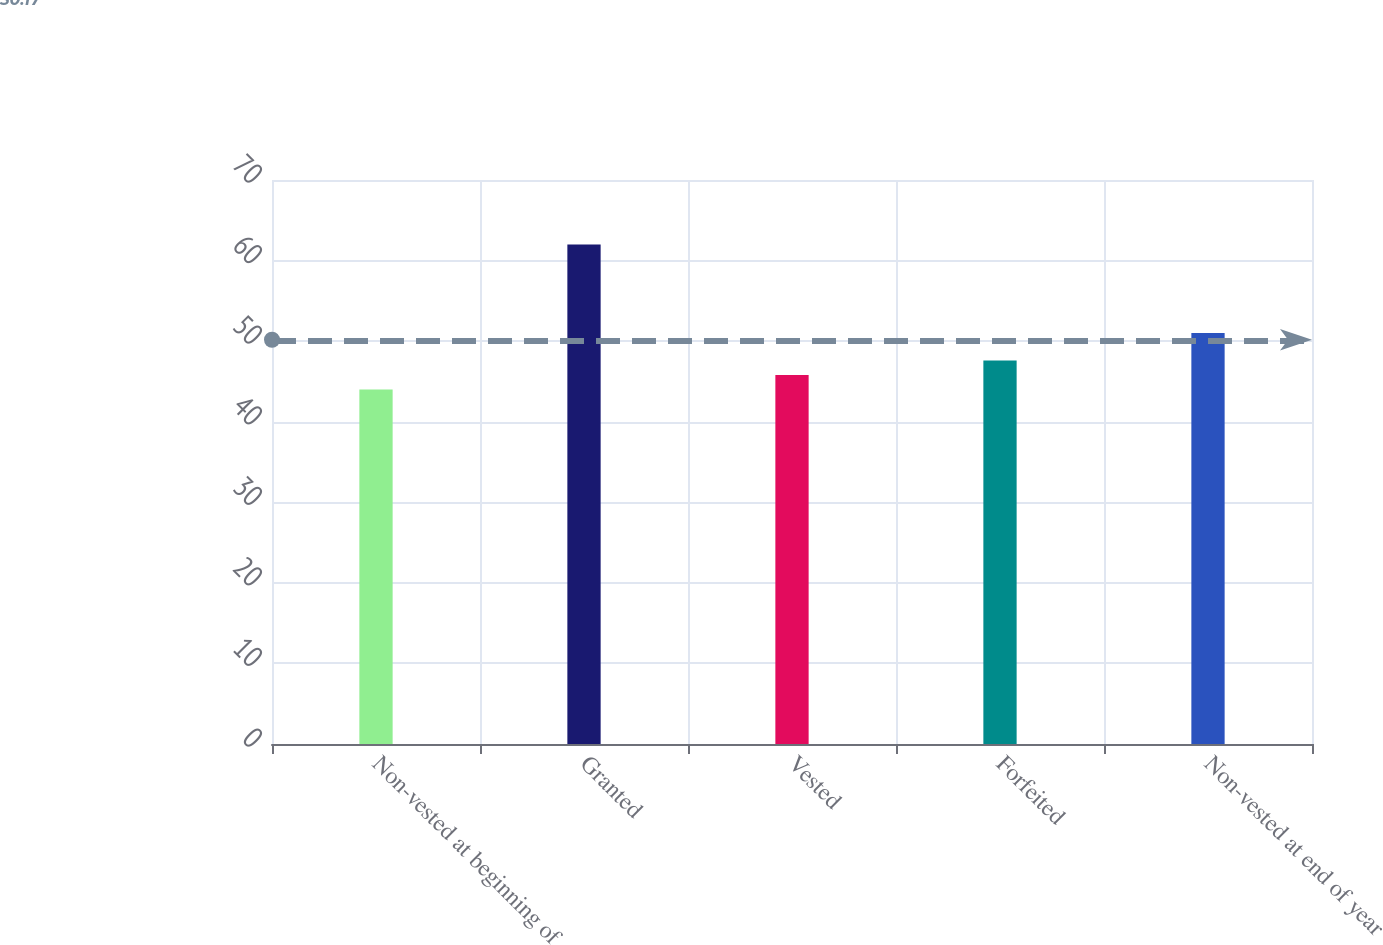Convert chart to OTSL. <chart><loc_0><loc_0><loc_500><loc_500><bar_chart><fcel>Non-vested at beginning of<fcel>Granted<fcel>Vested<fcel>Forfeited<fcel>Non-vested at end of year<nl><fcel>44<fcel>62<fcel>45.8<fcel>47.6<fcel>51<nl></chart> 